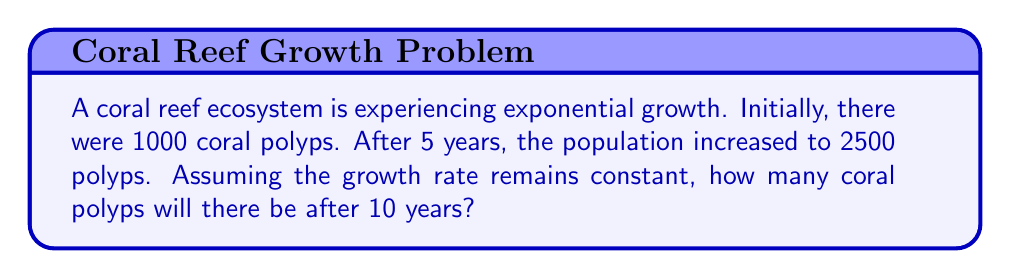Teach me how to tackle this problem. Let's approach this step-by-step:

1) The exponential growth model is given by the equation:
   $$P(t) = P_0 \cdot e^{rt}$$
   where $P(t)$ is the population at time $t$, $P_0$ is the initial population, $r$ is the growth rate, and $t$ is time.

2) We know:
   $P_0 = 1000$ (initial population)
   $P(5) = 2500$ (population after 5 years)
   We need to find $r$ (growth rate) first.

3) Plugging in the known values:
   $$2500 = 1000 \cdot e^{5r}$$

4) Dividing both sides by 1000:
   $$2.5 = e^{5r}$$

5) Taking the natural log of both sides:
   $$\ln(2.5) = 5r$$

6) Solving for $r$:
   $$r = \frac{\ln(2.5)}{5} \approx 0.1823$$

7) Now that we have $r$, we can use the original equation to find the population after 10 years:
   $$P(10) = 1000 \cdot e^{0.1823 \cdot 10}$$

8) Calculating:
   $$P(10) = 1000 \cdot e^{1.823} \approx 6188$$

Therefore, after 10 years, there will be approximately 6188 coral polyps.
Answer: 6188 coral polyps 